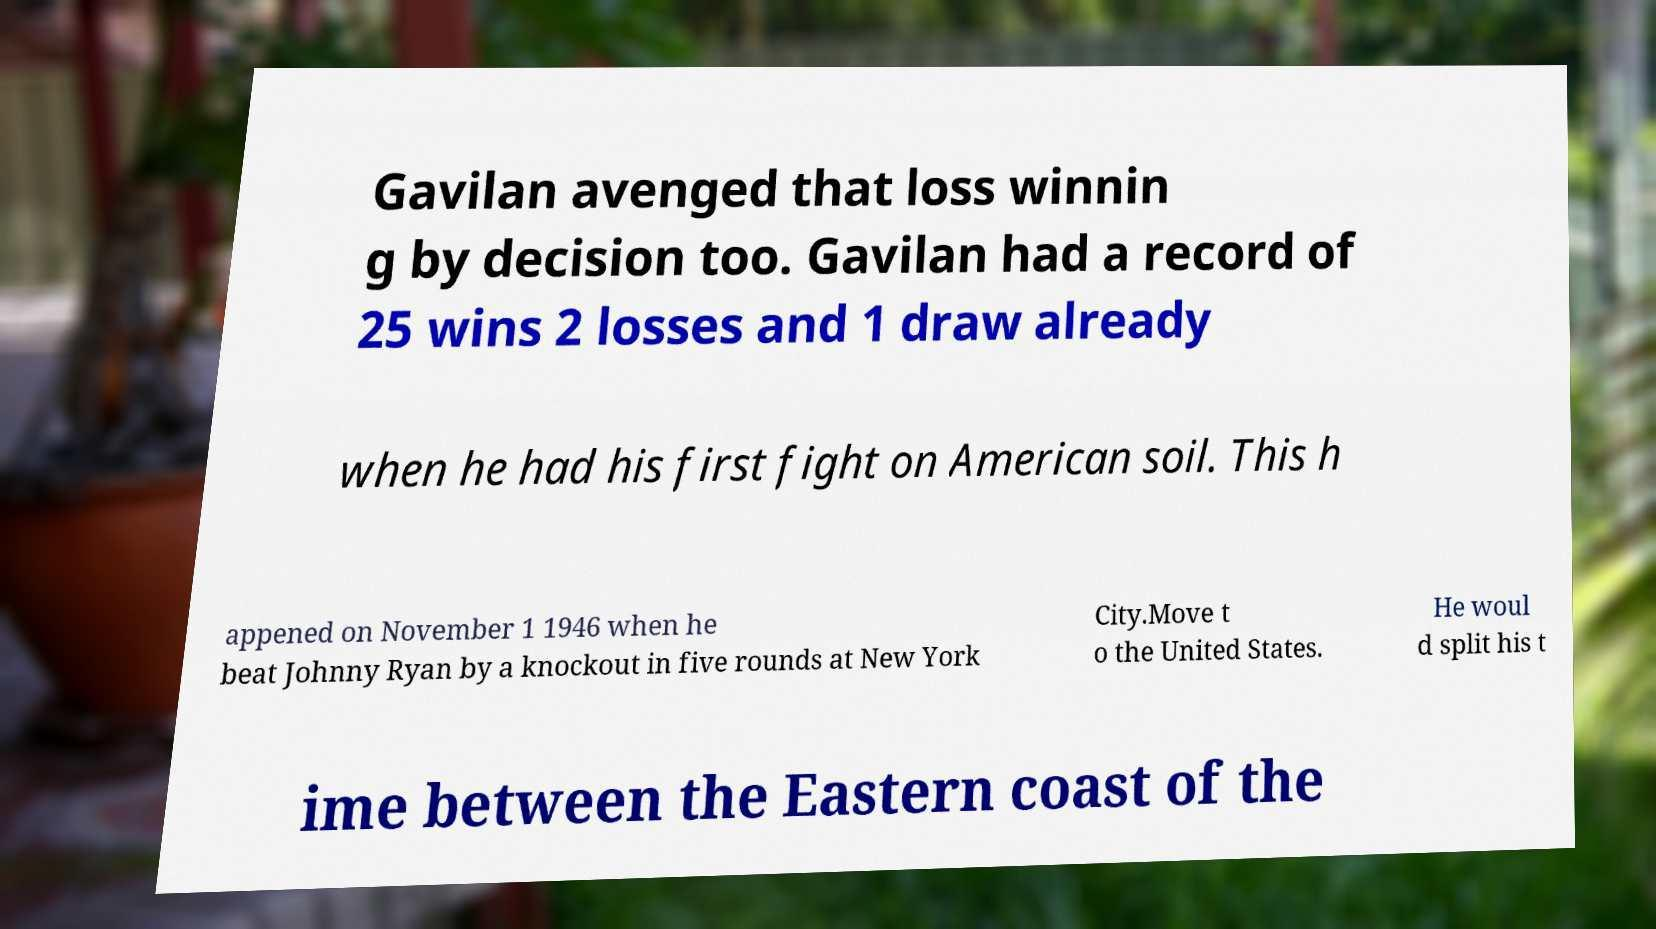Please identify and transcribe the text found in this image. Gavilan avenged that loss winnin g by decision too. Gavilan had a record of 25 wins 2 losses and 1 draw already when he had his first fight on American soil. This h appened on November 1 1946 when he beat Johnny Ryan by a knockout in five rounds at New York City.Move t o the United States. He woul d split his t ime between the Eastern coast of the 